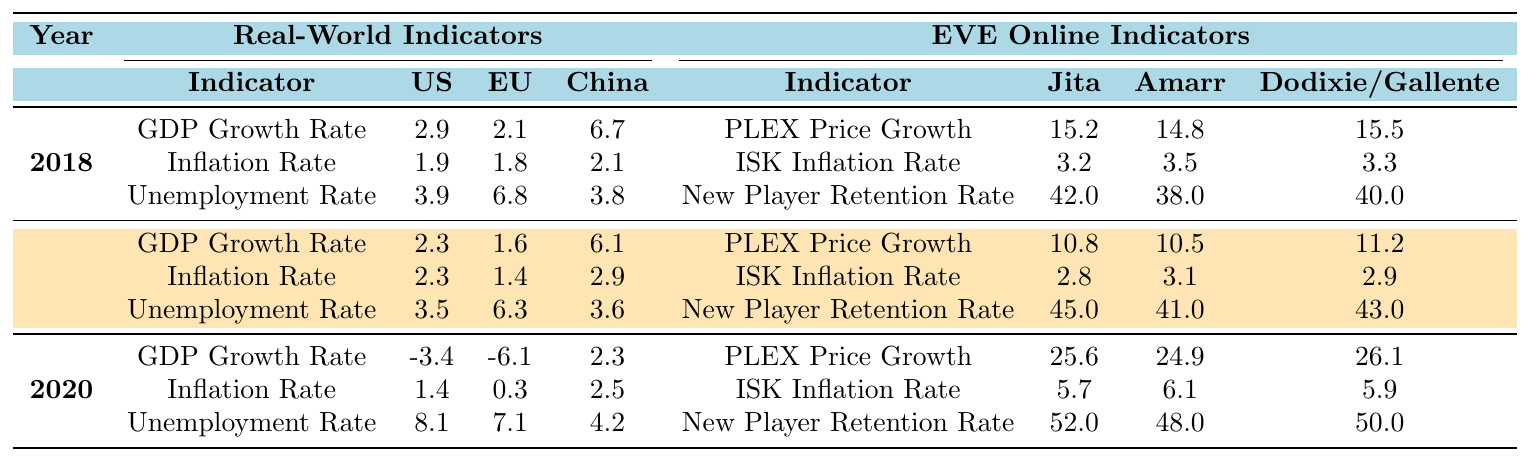What was the PLEX Price Growth in Jita for the year 2019? The table shows that in 2019, the PLEX Price Growth for Jita is 10.8.
Answer: 10.8 What is the difference in Unemployment Rates between the United States and the European Union in 2020? In 2020, the Unemployment Rate in the US is 8.1 and in the EU it is 7.1. The difference is 8.1 - 7.1 = 1.0.
Answer: 1.0 Which year had the highest ISK Inflation Rate in Amarr? From the table, in 2018 the ISK Inflation Rate in Amarr is 3.5, in 2019 it is 3.1, and in 2020 it is 6.1. The highest is 6.1 in 2020.
Answer: 2020 Did the New Player Retention Rate in the Calari faction increase from 2018 to 2020? The New Player Retention Rates for Caldari are 42 in 2018 and 52 in 2020. Since 52 is greater than 42, it did increase.
Answer: Yes What was the average GDP Growth Rate for China from 2018 to 2020? The GDP Growth Rates for China are 6.7 in 2018, 6.1 in 2019, and 2.3 in 2020. The sum is 6.7 + 6.1 + 2.3 = 15.1, and there are 3 years, so the average is 15.1 / 3 = 5.03.
Answer: 5.03 How did the Inflation Rate in the European Union change from 2018 to 2020? The Inflation Rates for the EU are 1.8 in 2018, 1.4 in 2019, and 0.3 in 2020. It decreased from 1.8 to 1.4 to 0.3, indicating a downward trend.
Answer: Decreased Which indicator had the largest increase in price growth from 2019 to 2020? The PLEX Price Growth in Jita rose from 10.8 in 2019 to 25.6 in 2020, while ISK Inflation Rate in Jita went from 2.8 to 5.7. The increase in PLEX Price Growth is larger (25.6 - 10.8 = 14.8) compared to ISK Inflation Rate (5.7 - 2.8 = 2.9).
Answer: PLEX Price Growth In which year did the United States have the lowest GDP Growth Rate? Referring to the table, in 2020, the GDP Growth Rate for the US is -3.4, which is lower than in 2018 (2.9) and 2019 (2.3).
Answer: 2020 What is the relationship between the GDP Growth Rate and Unemployment Rate in the United States for 2020? In 2020, the GDP Growth Rate is -3.4 and the Unemployment Rate is 8.1. Typically, negative GDP growth correlates with higher unemployment rates; here, we see 8.1 confirms that.
Answer: Positive correlation Compare the New Player Retention Rate in Amarr for 2019 and 2020. In the table, the New Player Retention Rate for Amarr is 41 in 2019 and 48 in 2020. This shows an increase of 7%.
Answer: Increased 